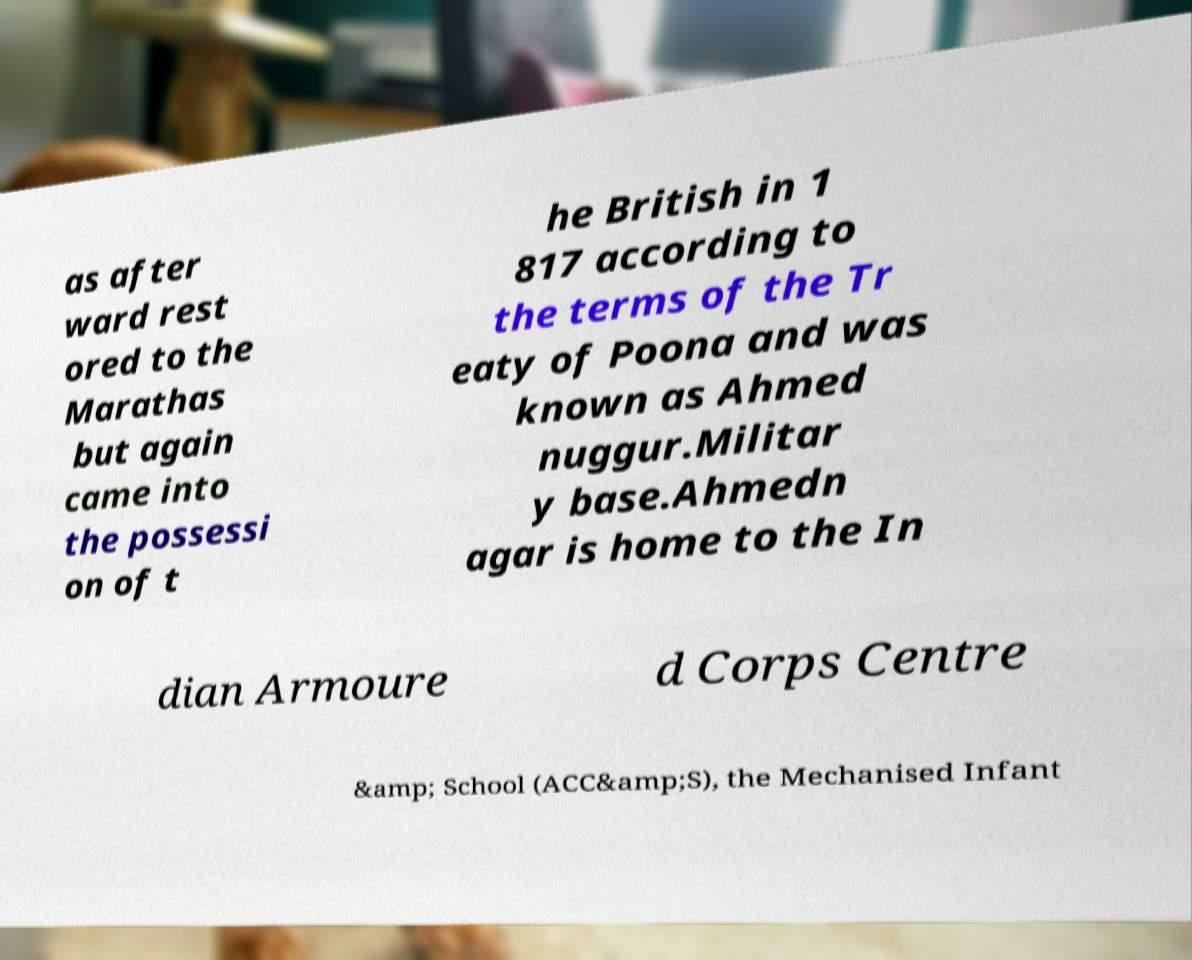Could you extract and type out the text from this image? as after ward rest ored to the Marathas but again came into the possessi on of t he British in 1 817 according to the terms of the Tr eaty of Poona and was known as Ahmed nuggur.Militar y base.Ahmedn agar is home to the In dian Armoure d Corps Centre &amp; School (ACC&amp;S), the Mechanised Infant 